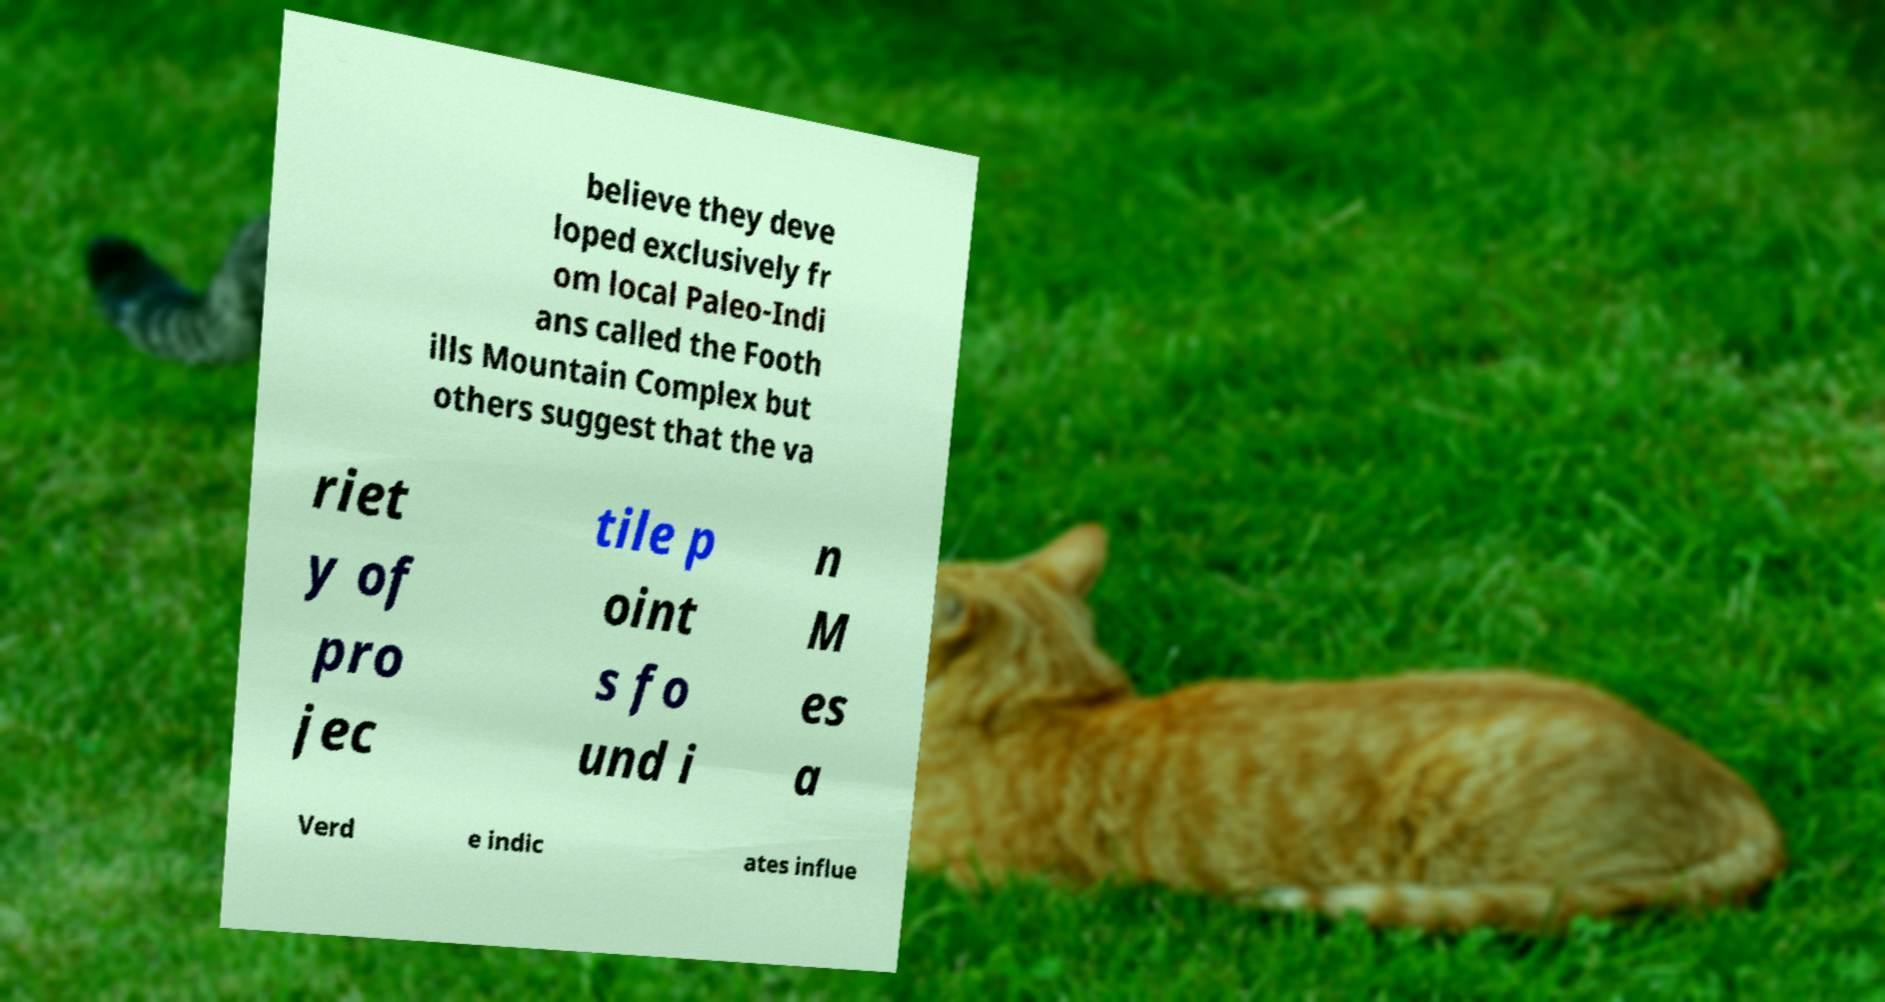There's text embedded in this image that I need extracted. Can you transcribe it verbatim? believe they deve loped exclusively fr om local Paleo-Indi ans called the Footh ills Mountain Complex but others suggest that the va riet y of pro jec tile p oint s fo und i n M es a Verd e indic ates influe 